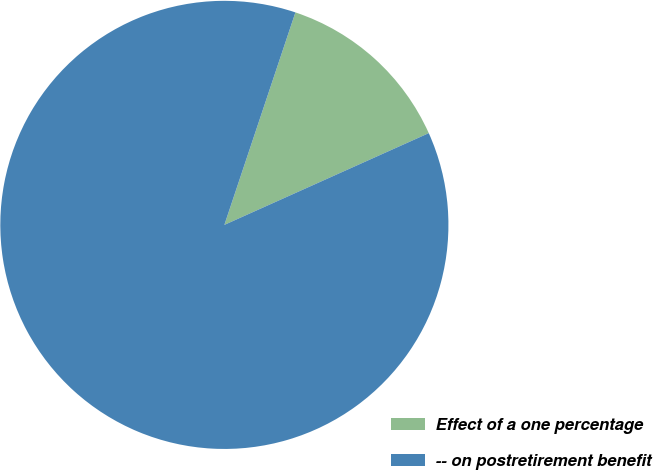Convert chart to OTSL. <chart><loc_0><loc_0><loc_500><loc_500><pie_chart><fcel>Effect of a one percentage<fcel>-- on postretirement benefit<nl><fcel>13.15%<fcel>86.85%<nl></chart> 